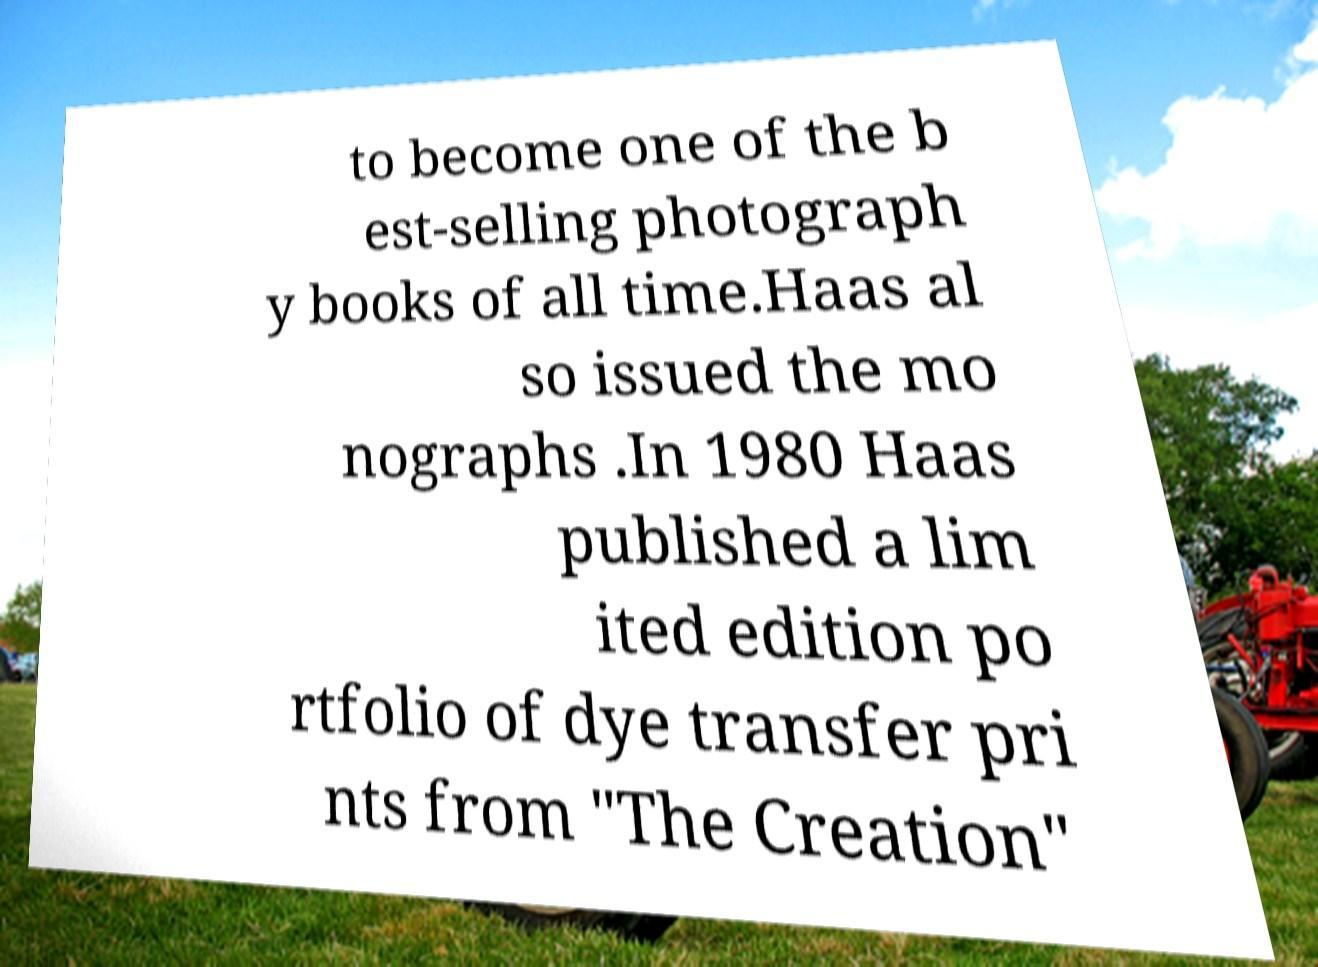Can you read and provide the text displayed in the image?This photo seems to have some interesting text. Can you extract and type it out for me? to become one of the b est-selling photograph y books of all time.Haas al so issued the mo nographs .In 1980 Haas published a lim ited edition po rtfolio of dye transfer pri nts from "The Creation" 